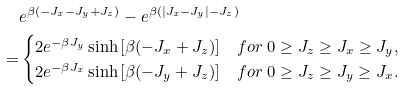<formula> <loc_0><loc_0><loc_500><loc_500>& e ^ { \beta ( - J _ { x } - J _ { y } + J _ { z } ) } - e ^ { \beta ( | J _ { x } - J _ { y } | - J _ { z } ) } \\ = & \begin{cases} 2 e ^ { - \beta J _ { y } } \sinh \left [ \beta ( - J _ { x } + J _ { z } ) \right ] & f o r \ 0 \geq J _ { z } \geq J _ { x } \geq J _ { y } , \\ 2 e ^ { - \beta J _ { x } } \sinh \left [ \beta ( - J _ { y } + J _ { z } ) \right ] & f o r \ 0 \geq J _ { z } \geq J _ { y } \geq J _ { x } . \end{cases}</formula> 